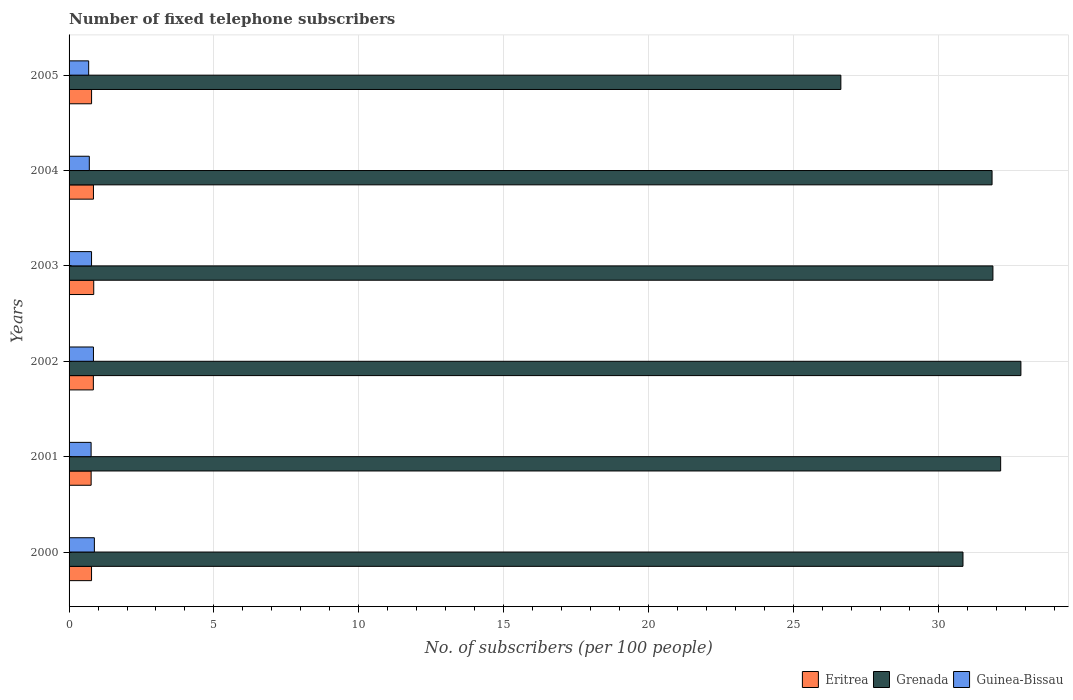Are the number of bars per tick equal to the number of legend labels?
Ensure brevity in your answer.  Yes. Are the number of bars on each tick of the Y-axis equal?
Your answer should be very brief. Yes. How many bars are there on the 6th tick from the top?
Keep it short and to the point. 3. How many bars are there on the 1st tick from the bottom?
Provide a short and direct response. 3. In how many cases, is the number of bars for a given year not equal to the number of legend labels?
Your answer should be very brief. 0. What is the number of fixed telephone subscribers in Eritrea in 2003?
Provide a short and direct response. 0.85. Across all years, what is the maximum number of fixed telephone subscribers in Guinea-Bissau?
Provide a short and direct response. 0.87. Across all years, what is the minimum number of fixed telephone subscribers in Eritrea?
Ensure brevity in your answer.  0.76. In which year was the number of fixed telephone subscribers in Guinea-Bissau maximum?
Provide a succinct answer. 2000. What is the total number of fixed telephone subscribers in Eritrea in the graph?
Your answer should be very brief. 4.85. What is the difference between the number of fixed telephone subscribers in Guinea-Bissau in 2003 and that in 2004?
Give a very brief answer. 0.08. What is the difference between the number of fixed telephone subscribers in Guinea-Bissau in 2004 and the number of fixed telephone subscribers in Grenada in 2003?
Ensure brevity in your answer.  -31.19. What is the average number of fixed telephone subscribers in Eritrea per year?
Keep it short and to the point. 0.81. In the year 2005, what is the difference between the number of fixed telephone subscribers in Guinea-Bissau and number of fixed telephone subscribers in Grenada?
Make the answer very short. -25.96. What is the ratio of the number of fixed telephone subscribers in Grenada in 2004 to that in 2005?
Provide a short and direct response. 1.2. Is the number of fixed telephone subscribers in Guinea-Bissau in 2000 less than that in 2001?
Your answer should be very brief. No. Is the difference between the number of fixed telephone subscribers in Guinea-Bissau in 2004 and 2005 greater than the difference between the number of fixed telephone subscribers in Grenada in 2004 and 2005?
Make the answer very short. No. What is the difference between the highest and the second highest number of fixed telephone subscribers in Grenada?
Offer a very short reply. 0.7. What is the difference between the highest and the lowest number of fixed telephone subscribers in Grenada?
Provide a succinct answer. 6.21. In how many years, is the number of fixed telephone subscribers in Grenada greater than the average number of fixed telephone subscribers in Grenada taken over all years?
Your answer should be very brief. 4. What does the 3rd bar from the top in 2003 represents?
Offer a very short reply. Eritrea. What does the 3rd bar from the bottom in 2005 represents?
Provide a succinct answer. Guinea-Bissau. How many bars are there?
Make the answer very short. 18. Are all the bars in the graph horizontal?
Ensure brevity in your answer.  Yes. How many years are there in the graph?
Offer a terse response. 6. Are the values on the major ticks of X-axis written in scientific E-notation?
Offer a terse response. No. Does the graph contain any zero values?
Offer a terse response. No. What is the title of the graph?
Provide a short and direct response. Number of fixed telephone subscribers. What is the label or title of the X-axis?
Give a very brief answer. No. of subscribers (per 100 people). What is the label or title of the Y-axis?
Provide a short and direct response. Years. What is the No. of subscribers (per 100 people) of Eritrea in 2000?
Your answer should be very brief. 0.78. What is the No. of subscribers (per 100 people) of Grenada in 2000?
Your answer should be very brief. 30.86. What is the No. of subscribers (per 100 people) of Guinea-Bissau in 2000?
Offer a very short reply. 0.87. What is the No. of subscribers (per 100 people) of Eritrea in 2001?
Provide a succinct answer. 0.76. What is the No. of subscribers (per 100 people) of Grenada in 2001?
Your answer should be very brief. 32.16. What is the No. of subscribers (per 100 people) of Guinea-Bissau in 2001?
Provide a succinct answer. 0.76. What is the No. of subscribers (per 100 people) of Eritrea in 2002?
Keep it short and to the point. 0.84. What is the No. of subscribers (per 100 people) in Grenada in 2002?
Keep it short and to the point. 32.85. What is the No. of subscribers (per 100 people) of Guinea-Bissau in 2002?
Provide a short and direct response. 0.84. What is the No. of subscribers (per 100 people) of Eritrea in 2003?
Ensure brevity in your answer.  0.85. What is the No. of subscribers (per 100 people) of Grenada in 2003?
Provide a succinct answer. 31.89. What is the No. of subscribers (per 100 people) of Guinea-Bissau in 2003?
Offer a very short reply. 0.78. What is the No. of subscribers (per 100 people) of Eritrea in 2004?
Your answer should be very brief. 0.84. What is the No. of subscribers (per 100 people) in Grenada in 2004?
Provide a succinct answer. 31.86. What is the No. of subscribers (per 100 people) in Guinea-Bissau in 2004?
Your response must be concise. 0.7. What is the No. of subscribers (per 100 people) of Eritrea in 2005?
Your answer should be very brief. 0.78. What is the No. of subscribers (per 100 people) in Grenada in 2005?
Provide a short and direct response. 26.64. What is the No. of subscribers (per 100 people) in Guinea-Bissau in 2005?
Provide a short and direct response. 0.68. Across all years, what is the maximum No. of subscribers (per 100 people) in Eritrea?
Provide a short and direct response. 0.85. Across all years, what is the maximum No. of subscribers (per 100 people) in Grenada?
Offer a terse response. 32.85. Across all years, what is the maximum No. of subscribers (per 100 people) in Guinea-Bissau?
Your answer should be compact. 0.87. Across all years, what is the minimum No. of subscribers (per 100 people) of Eritrea?
Keep it short and to the point. 0.76. Across all years, what is the minimum No. of subscribers (per 100 people) of Grenada?
Provide a succinct answer. 26.64. Across all years, what is the minimum No. of subscribers (per 100 people) of Guinea-Bissau?
Provide a short and direct response. 0.68. What is the total No. of subscribers (per 100 people) of Eritrea in the graph?
Make the answer very short. 4.85. What is the total No. of subscribers (per 100 people) of Grenada in the graph?
Make the answer very short. 186.25. What is the total No. of subscribers (per 100 people) in Guinea-Bissau in the graph?
Your answer should be compact. 4.63. What is the difference between the No. of subscribers (per 100 people) of Eritrea in 2000 and that in 2001?
Make the answer very short. 0.01. What is the difference between the No. of subscribers (per 100 people) of Grenada in 2000 and that in 2001?
Provide a succinct answer. -1.3. What is the difference between the No. of subscribers (per 100 people) of Guinea-Bissau in 2000 and that in 2001?
Keep it short and to the point. 0.11. What is the difference between the No. of subscribers (per 100 people) in Eritrea in 2000 and that in 2002?
Offer a very short reply. -0.06. What is the difference between the No. of subscribers (per 100 people) in Grenada in 2000 and that in 2002?
Offer a terse response. -2. What is the difference between the No. of subscribers (per 100 people) of Guinea-Bissau in 2000 and that in 2002?
Offer a terse response. 0.03. What is the difference between the No. of subscribers (per 100 people) in Eritrea in 2000 and that in 2003?
Make the answer very short. -0.08. What is the difference between the No. of subscribers (per 100 people) of Grenada in 2000 and that in 2003?
Give a very brief answer. -1.03. What is the difference between the No. of subscribers (per 100 people) in Guinea-Bissau in 2000 and that in 2003?
Your answer should be very brief. 0.1. What is the difference between the No. of subscribers (per 100 people) in Eritrea in 2000 and that in 2004?
Offer a terse response. -0.07. What is the difference between the No. of subscribers (per 100 people) of Grenada in 2000 and that in 2004?
Provide a short and direct response. -1. What is the difference between the No. of subscribers (per 100 people) in Guinea-Bissau in 2000 and that in 2004?
Offer a very short reply. 0.17. What is the difference between the No. of subscribers (per 100 people) in Eritrea in 2000 and that in 2005?
Offer a terse response. -0. What is the difference between the No. of subscribers (per 100 people) in Grenada in 2000 and that in 2005?
Provide a short and direct response. 4.22. What is the difference between the No. of subscribers (per 100 people) in Guinea-Bissau in 2000 and that in 2005?
Keep it short and to the point. 0.2. What is the difference between the No. of subscribers (per 100 people) in Eritrea in 2001 and that in 2002?
Provide a succinct answer. -0.08. What is the difference between the No. of subscribers (per 100 people) in Grenada in 2001 and that in 2002?
Offer a very short reply. -0.7. What is the difference between the No. of subscribers (per 100 people) in Guinea-Bissau in 2001 and that in 2002?
Give a very brief answer. -0.08. What is the difference between the No. of subscribers (per 100 people) in Eritrea in 2001 and that in 2003?
Provide a succinct answer. -0.09. What is the difference between the No. of subscribers (per 100 people) in Grenada in 2001 and that in 2003?
Offer a very short reply. 0.27. What is the difference between the No. of subscribers (per 100 people) in Guinea-Bissau in 2001 and that in 2003?
Provide a succinct answer. -0.02. What is the difference between the No. of subscribers (per 100 people) in Eritrea in 2001 and that in 2004?
Your answer should be very brief. -0.08. What is the difference between the No. of subscribers (per 100 people) in Grenada in 2001 and that in 2004?
Provide a short and direct response. 0.3. What is the difference between the No. of subscribers (per 100 people) of Guinea-Bissau in 2001 and that in 2004?
Your answer should be compact. 0.06. What is the difference between the No. of subscribers (per 100 people) of Eritrea in 2001 and that in 2005?
Offer a very short reply. -0.01. What is the difference between the No. of subscribers (per 100 people) in Grenada in 2001 and that in 2005?
Provide a short and direct response. 5.52. What is the difference between the No. of subscribers (per 100 people) in Guinea-Bissau in 2001 and that in 2005?
Your answer should be very brief. 0.08. What is the difference between the No. of subscribers (per 100 people) of Eritrea in 2002 and that in 2003?
Keep it short and to the point. -0.01. What is the difference between the No. of subscribers (per 100 people) of Grenada in 2002 and that in 2003?
Your answer should be very brief. 0.97. What is the difference between the No. of subscribers (per 100 people) in Guinea-Bissau in 2002 and that in 2003?
Provide a succinct answer. 0.07. What is the difference between the No. of subscribers (per 100 people) of Eritrea in 2002 and that in 2004?
Provide a short and direct response. -0. What is the difference between the No. of subscribers (per 100 people) in Grenada in 2002 and that in 2004?
Your response must be concise. 1. What is the difference between the No. of subscribers (per 100 people) in Guinea-Bissau in 2002 and that in 2004?
Provide a succinct answer. 0.14. What is the difference between the No. of subscribers (per 100 people) in Eritrea in 2002 and that in 2005?
Provide a short and direct response. 0.06. What is the difference between the No. of subscribers (per 100 people) of Grenada in 2002 and that in 2005?
Keep it short and to the point. 6.21. What is the difference between the No. of subscribers (per 100 people) in Guinea-Bissau in 2002 and that in 2005?
Keep it short and to the point. 0.17. What is the difference between the No. of subscribers (per 100 people) of Eritrea in 2003 and that in 2004?
Ensure brevity in your answer.  0.01. What is the difference between the No. of subscribers (per 100 people) in Grenada in 2003 and that in 2004?
Give a very brief answer. 0.03. What is the difference between the No. of subscribers (per 100 people) in Guinea-Bissau in 2003 and that in 2004?
Provide a succinct answer. 0.08. What is the difference between the No. of subscribers (per 100 people) in Eritrea in 2003 and that in 2005?
Make the answer very short. 0.07. What is the difference between the No. of subscribers (per 100 people) of Grenada in 2003 and that in 2005?
Offer a very short reply. 5.25. What is the difference between the No. of subscribers (per 100 people) in Guinea-Bissau in 2003 and that in 2005?
Offer a very short reply. 0.1. What is the difference between the No. of subscribers (per 100 people) of Eritrea in 2004 and that in 2005?
Provide a succinct answer. 0.06. What is the difference between the No. of subscribers (per 100 people) in Grenada in 2004 and that in 2005?
Provide a succinct answer. 5.22. What is the difference between the No. of subscribers (per 100 people) in Guinea-Bissau in 2004 and that in 2005?
Give a very brief answer. 0.02. What is the difference between the No. of subscribers (per 100 people) in Eritrea in 2000 and the No. of subscribers (per 100 people) in Grenada in 2001?
Give a very brief answer. -31.38. What is the difference between the No. of subscribers (per 100 people) in Eritrea in 2000 and the No. of subscribers (per 100 people) in Guinea-Bissau in 2001?
Make the answer very short. 0.01. What is the difference between the No. of subscribers (per 100 people) of Grenada in 2000 and the No. of subscribers (per 100 people) of Guinea-Bissau in 2001?
Offer a very short reply. 30.09. What is the difference between the No. of subscribers (per 100 people) of Eritrea in 2000 and the No. of subscribers (per 100 people) of Grenada in 2002?
Provide a succinct answer. -32.08. What is the difference between the No. of subscribers (per 100 people) of Eritrea in 2000 and the No. of subscribers (per 100 people) of Guinea-Bissau in 2002?
Your answer should be very brief. -0.07. What is the difference between the No. of subscribers (per 100 people) of Grenada in 2000 and the No. of subscribers (per 100 people) of Guinea-Bissau in 2002?
Keep it short and to the point. 30.01. What is the difference between the No. of subscribers (per 100 people) of Eritrea in 2000 and the No. of subscribers (per 100 people) of Grenada in 2003?
Keep it short and to the point. -31.11. What is the difference between the No. of subscribers (per 100 people) in Eritrea in 2000 and the No. of subscribers (per 100 people) in Guinea-Bissau in 2003?
Offer a terse response. -0. What is the difference between the No. of subscribers (per 100 people) of Grenada in 2000 and the No. of subscribers (per 100 people) of Guinea-Bissau in 2003?
Provide a succinct answer. 30.08. What is the difference between the No. of subscribers (per 100 people) in Eritrea in 2000 and the No. of subscribers (per 100 people) in Grenada in 2004?
Provide a succinct answer. -31.08. What is the difference between the No. of subscribers (per 100 people) in Eritrea in 2000 and the No. of subscribers (per 100 people) in Guinea-Bissau in 2004?
Ensure brevity in your answer.  0.08. What is the difference between the No. of subscribers (per 100 people) of Grenada in 2000 and the No. of subscribers (per 100 people) of Guinea-Bissau in 2004?
Provide a succinct answer. 30.16. What is the difference between the No. of subscribers (per 100 people) in Eritrea in 2000 and the No. of subscribers (per 100 people) in Grenada in 2005?
Give a very brief answer. -25.86. What is the difference between the No. of subscribers (per 100 people) of Eritrea in 2000 and the No. of subscribers (per 100 people) of Guinea-Bissau in 2005?
Your answer should be compact. 0.1. What is the difference between the No. of subscribers (per 100 people) of Grenada in 2000 and the No. of subscribers (per 100 people) of Guinea-Bissau in 2005?
Your response must be concise. 30.18. What is the difference between the No. of subscribers (per 100 people) of Eritrea in 2001 and the No. of subscribers (per 100 people) of Grenada in 2002?
Keep it short and to the point. -32.09. What is the difference between the No. of subscribers (per 100 people) of Eritrea in 2001 and the No. of subscribers (per 100 people) of Guinea-Bissau in 2002?
Provide a short and direct response. -0.08. What is the difference between the No. of subscribers (per 100 people) of Grenada in 2001 and the No. of subscribers (per 100 people) of Guinea-Bissau in 2002?
Your response must be concise. 31.31. What is the difference between the No. of subscribers (per 100 people) of Eritrea in 2001 and the No. of subscribers (per 100 people) of Grenada in 2003?
Provide a succinct answer. -31.13. What is the difference between the No. of subscribers (per 100 people) of Eritrea in 2001 and the No. of subscribers (per 100 people) of Guinea-Bissau in 2003?
Keep it short and to the point. -0.01. What is the difference between the No. of subscribers (per 100 people) of Grenada in 2001 and the No. of subscribers (per 100 people) of Guinea-Bissau in 2003?
Your response must be concise. 31.38. What is the difference between the No. of subscribers (per 100 people) of Eritrea in 2001 and the No. of subscribers (per 100 people) of Grenada in 2004?
Ensure brevity in your answer.  -31.1. What is the difference between the No. of subscribers (per 100 people) in Eritrea in 2001 and the No. of subscribers (per 100 people) in Guinea-Bissau in 2004?
Provide a short and direct response. 0.06. What is the difference between the No. of subscribers (per 100 people) of Grenada in 2001 and the No. of subscribers (per 100 people) of Guinea-Bissau in 2004?
Your response must be concise. 31.46. What is the difference between the No. of subscribers (per 100 people) in Eritrea in 2001 and the No. of subscribers (per 100 people) in Grenada in 2005?
Your response must be concise. -25.88. What is the difference between the No. of subscribers (per 100 people) in Eritrea in 2001 and the No. of subscribers (per 100 people) in Guinea-Bissau in 2005?
Your response must be concise. 0.09. What is the difference between the No. of subscribers (per 100 people) in Grenada in 2001 and the No. of subscribers (per 100 people) in Guinea-Bissau in 2005?
Your answer should be very brief. 31.48. What is the difference between the No. of subscribers (per 100 people) in Eritrea in 2002 and the No. of subscribers (per 100 people) in Grenada in 2003?
Your answer should be very brief. -31.05. What is the difference between the No. of subscribers (per 100 people) in Eritrea in 2002 and the No. of subscribers (per 100 people) in Guinea-Bissau in 2003?
Provide a succinct answer. 0.06. What is the difference between the No. of subscribers (per 100 people) of Grenada in 2002 and the No. of subscribers (per 100 people) of Guinea-Bissau in 2003?
Ensure brevity in your answer.  32.08. What is the difference between the No. of subscribers (per 100 people) of Eritrea in 2002 and the No. of subscribers (per 100 people) of Grenada in 2004?
Your answer should be very brief. -31.02. What is the difference between the No. of subscribers (per 100 people) of Eritrea in 2002 and the No. of subscribers (per 100 people) of Guinea-Bissau in 2004?
Offer a terse response. 0.14. What is the difference between the No. of subscribers (per 100 people) of Grenada in 2002 and the No. of subscribers (per 100 people) of Guinea-Bissau in 2004?
Make the answer very short. 32.16. What is the difference between the No. of subscribers (per 100 people) in Eritrea in 2002 and the No. of subscribers (per 100 people) in Grenada in 2005?
Ensure brevity in your answer.  -25.8. What is the difference between the No. of subscribers (per 100 people) of Eritrea in 2002 and the No. of subscribers (per 100 people) of Guinea-Bissau in 2005?
Provide a short and direct response. 0.16. What is the difference between the No. of subscribers (per 100 people) in Grenada in 2002 and the No. of subscribers (per 100 people) in Guinea-Bissau in 2005?
Provide a short and direct response. 32.18. What is the difference between the No. of subscribers (per 100 people) in Eritrea in 2003 and the No. of subscribers (per 100 people) in Grenada in 2004?
Give a very brief answer. -31.01. What is the difference between the No. of subscribers (per 100 people) of Eritrea in 2003 and the No. of subscribers (per 100 people) of Guinea-Bissau in 2004?
Give a very brief answer. 0.15. What is the difference between the No. of subscribers (per 100 people) of Grenada in 2003 and the No. of subscribers (per 100 people) of Guinea-Bissau in 2004?
Your answer should be very brief. 31.19. What is the difference between the No. of subscribers (per 100 people) in Eritrea in 2003 and the No. of subscribers (per 100 people) in Grenada in 2005?
Your answer should be compact. -25.79. What is the difference between the No. of subscribers (per 100 people) of Eritrea in 2003 and the No. of subscribers (per 100 people) of Guinea-Bissau in 2005?
Provide a succinct answer. 0.18. What is the difference between the No. of subscribers (per 100 people) in Grenada in 2003 and the No. of subscribers (per 100 people) in Guinea-Bissau in 2005?
Give a very brief answer. 31.21. What is the difference between the No. of subscribers (per 100 people) of Eritrea in 2004 and the No. of subscribers (per 100 people) of Grenada in 2005?
Ensure brevity in your answer.  -25.8. What is the difference between the No. of subscribers (per 100 people) of Eritrea in 2004 and the No. of subscribers (per 100 people) of Guinea-Bissau in 2005?
Ensure brevity in your answer.  0.17. What is the difference between the No. of subscribers (per 100 people) of Grenada in 2004 and the No. of subscribers (per 100 people) of Guinea-Bissau in 2005?
Ensure brevity in your answer.  31.18. What is the average No. of subscribers (per 100 people) in Eritrea per year?
Provide a short and direct response. 0.81. What is the average No. of subscribers (per 100 people) of Grenada per year?
Your answer should be very brief. 31.04. What is the average No. of subscribers (per 100 people) in Guinea-Bissau per year?
Keep it short and to the point. 0.77. In the year 2000, what is the difference between the No. of subscribers (per 100 people) in Eritrea and No. of subscribers (per 100 people) in Grenada?
Keep it short and to the point. -30.08. In the year 2000, what is the difference between the No. of subscribers (per 100 people) in Eritrea and No. of subscribers (per 100 people) in Guinea-Bissau?
Your answer should be very brief. -0.1. In the year 2000, what is the difference between the No. of subscribers (per 100 people) of Grenada and No. of subscribers (per 100 people) of Guinea-Bissau?
Give a very brief answer. 29.98. In the year 2001, what is the difference between the No. of subscribers (per 100 people) in Eritrea and No. of subscribers (per 100 people) in Grenada?
Keep it short and to the point. -31.39. In the year 2001, what is the difference between the No. of subscribers (per 100 people) in Eritrea and No. of subscribers (per 100 people) in Guinea-Bissau?
Your answer should be compact. 0. In the year 2001, what is the difference between the No. of subscribers (per 100 people) in Grenada and No. of subscribers (per 100 people) in Guinea-Bissau?
Your answer should be compact. 31.39. In the year 2002, what is the difference between the No. of subscribers (per 100 people) of Eritrea and No. of subscribers (per 100 people) of Grenada?
Ensure brevity in your answer.  -32.02. In the year 2002, what is the difference between the No. of subscribers (per 100 people) of Eritrea and No. of subscribers (per 100 people) of Guinea-Bissau?
Your answer should be compact. -0. In the year 2002, what is the difference between the No. of subscribers (per 100 people) of Grenada and No. of subscribers (per 100 people) of Guinea-Bissau?
Provide a short and direct response. 32.01. In the year 2003, what is the difference between the No. of subscribers (per 100 people) of Eritrea and No. of subscribers (per 100 people) of Grenada?
Provide a succinct answer. -31.04. In the year 2003, what is the difference between the No. of subscribers (per 100 people) of Eritrea and No. of subscribers (per 100 people) of Guinea-Bissau?
Your answer should be very brief. 0.08. In the year 2003, what is the difference between the No. of subscribers (per 100 people) of Grenada and No. of subscribers (per 100 people) of Guinea-Bissau?
Provide a short and direct response. 31.11. In the year 2004, what is the difference between the No. of subscribers (per 100 people) in Eritrea and No. of subscribers (per 100 people) in Grenada?
Ensure brevity in your answer.  -31.02. In the year 2004, what is the difference between the No. of subscribers (per 100 people) of Eritrea and No. of subscribers (per 100 people) of Guinea-Bissau?
Your response must be concise. 0.14. In the year 2004, what is the difference between the No. of subscribers (per 100 people) in Grenada and No. of subscribers (per 100 people) in Guinea-Bissau?
Your answer should be very brief. 31.16. In the year 2005, what is the difference between the No. of subscribers (per 100 people) of Eritrea and No. of subscribers (per 100 people) of Grenada?
Ensure brevity in your answer.  -25.86. In the year 2005, what is the difference between the No. of subscribers (per 100 people) in Eritrea and No. of subscribers (per 100 people) in Guinea-Bissau?
Provide a succinct answer. 0.1. In the year 2005, what is the difference between the No. of subscribers (per 100 people) of Grenada and No. of subscribers (per 100 people) of Guinea-Bissau?
Provide a succinct answer. 25.96. What is the ratio of the No. of subscribers (per 100 people) in Eritrea in 2000 to that in 2001?
Your answer should be very brief. 1.02. What is the ratio of the No. of subscribers (per 100 people) in Grenada in 2000 to that in 2001?
Make the answer very short. 0.96. What is the ratio of the No. of subscribers (per 100 people) in Guinea-Bissau in 2000 to that in 2001?
Ensure brevity in your answer.  1.15. What is the ratio of the No. of subscribers (per 100 people) in Eritrea in 2000 to that in 2002?
Ensure brevity in your answer.  0.93. What is the ratio of the No. of subscribers (per 100 people) of Grenada in 2000 to that in 2002?
Offer a terse response. 0.94. What is the ratio of the No. of subscribers (per 100 people) of Guinea-Bissau in 2000 to that in 2002?
Give a very brief answer. 1.04. What is the ratio of the No. of subscribers (per 100 people) in Eritrea in 2000 to that in 2003?
Your answer should be very brief. 0.91. What is the ratio of the No. of subscribers (per 100 people) in Grenada in 2000 to that in 2003?
Keep it short and to the point. 0.97. What is the ratio of the No. of subscribers (per 100 people) in Guinea-Bissau in 2000 to that in 2003?
Ensure brevity in your answer.  1.13. What is the ratio of the No. of subscribers (per 100 people) in Eritrea in 2000 to that in 2004?
Offer a very short reply. 0.92. What is the ratio of the No. of subscribers (per 100 people) in Grenada in 2000 to that in 2004?
Provide a succinct answer. 0.97. What is the ratio of the No. of subscribers (per 100 people) of Guinea-Bissau in 2000 to that in 2004?
Offer a very short reply. 1.25. What is the ratio of the No. of subscribers (per 100 people) of Eritrea in 2000 to that in 2005?
Your answer should be compact. 1. What is the ratio of the No. of subscribers (per 100 people) of Grenada in 2000 to that in 2005?
Ensure brevity in your answer.  1.16. What is the ratio of the No. of subscribers (per 100 people) of Guinea-Bissau in 2000 to that in 2005?
Make the answer very short. 1.29. What is the ratio of the No. of subscribers (per 100 people) in Eritrea in 2001 to that in 2002?
Give a very brief answer. 0.91. What is the ratio of the No. of subscribers (per 100 people) of Grenada in 2001 to that in 2002?
Keep it short and to the point. 0.98. What is the ratio of the No. of subscribers (per 100 people) of Guinea-Bissau in 2001 to that in 2002?
Your answer should be very brief. 0.9. What is the ratio of the No. of subscribers (per 100 people) in Eritrea in 2001 to that in 2003?
Ensure brevity in your answer.  0.89. What is the ratio of the No. of subscribers (per 100 people) of Grenada in 2001 to that in 2003?
Your response must be concise. 1.01. What is the ratio of the No. of subscribers (per 100 people) in Guinea-Bissau in 2001 to that in 2003?
Your answer should be very brief. 0.98. What is the ratio of the No. of subscribers (per 100 people) of Eritrea in 2001 to that in 2004?
Provide a succinct answer. 0.91. What is the ratio of the No. of subscribers (per 100 people) in Grenada in 2001 to that in 2004?
Ensure brevity in your answer.  1.01. What is the ratio of the No. of subscribers (per 100 people) in Guinea-Bissau in 2001 to that in 2004?
Ensure brevity in your answer.  1.09. What is the ratio of the No. of subscribers (per 100 people) in Eritrea in 2001 to that in 2005?
Keep it short and to the point. 0.98. What is the ratio of the No. of subscribers (per 100 people) of Grenada in 2001 to that in 2005?
Make the answer very short. 1.21. What is the ratio of the No. of subscribers (per 100 people) of Guinea-Bissau in 2001 to that in 2005?
Your answer should be very brief. 1.12. What is the ratio of the No. of subscribers (per 100 people) of Grenada in 2002 to that in 2003?
Provide a short and direct response. 1.03. What is the ratio of the No. of subscribers (per 100 people) of Guinea-Bissau in 2002 to that in 2003?
Your response must be concise. 1.08. What is the ratio of the No. of subscribers (per 100 people) of Eritrea in 2002 to that in 2004?
Make the answer very short. 1. What is the ratio of the No. of subscribers (per 100 people) of Grenada in 2002 to that in 2004?
Offer a terse response. 1.03. What is the ratio of the No. of subscribers (per 100 people) of Guinea-Bissau in 2002 to that in 2004?
Give a very brief answer. 1.2. What is the ratio of the No. of subscribers (per 100 people) of Eritrea in 2002 to that in 2005?
Your answer should be compact. 1.08. What is the ratio of the No. of subscribers (per 100 people) in Grenada in 2002 to that in 2005?
Offer a terse response. 1.23. What is the ratio of the No. of subscribers (per 100 people) in Guinea-Bissau in 2002 to that in 2005?
Your response must be concise. 1.24. What is the ratio of the No. of subscribers (per 100 people) in Eritrea in 2003 to that in 2004?
Ensure brevity in your answer.  1.01. What is the ratio of the No. of subscribers (per 100 people) in Guinea-Bissau in 2003 to that in 2004?
Ensure brevity in your answer.  1.11. What is the ratio of the No. of subscribers (per 100 people) in Eritrea in 2003 to that in 2005?
Offer a terse response. 1.1. What is the ratio of the No. of subscribers (per 100 people) in Grenada in 2003 to that in 2005?
Your answer should be compact. 1.2. What is the ratio of the No. of subscribers (per 100 people) in Guinea-Bissau in 2003 to that in 2005?
Your answer should be compact. 1.15. What is the ratio of the No. of subscribers (per 100 people) in Eritrea in 2004 to that in 2005?
Offer a very short reply. 1.08. What is the ratio of the No. of subscribers (per 100 people) of Grenada in 2004 to that in 2005?
Your answer should be very brief. 1.2. What is the difference between the highest and the second highest No. of subscribers (per 100 people) in Eritrea?
Provide a succinct answer. 0.01. What is the difference between the highest and the second highest No. of subscribers (per 100 people) of Grenada?
Provide a succinct answer. 0.7. What is the difference between the highest and the second highest No. of subscribers (per 100 people) of Guinea-Bissau?
Provide a short and direct response. 0.03. What is the difference between the highest and the lowest No. of subscribers (per 100 people) in Eritrea?
Ensure brevity in your answer.  0.09. What is the difference between the highest and the lowest No. of subscribers (per 100 people) of Grenada?
Offer a very short reply. 6.21. What is the difference between the highest and the lowest No. of subscribers (per 100 people) of Guinea-Bissau?
Give a very brief answer. 0.2. 